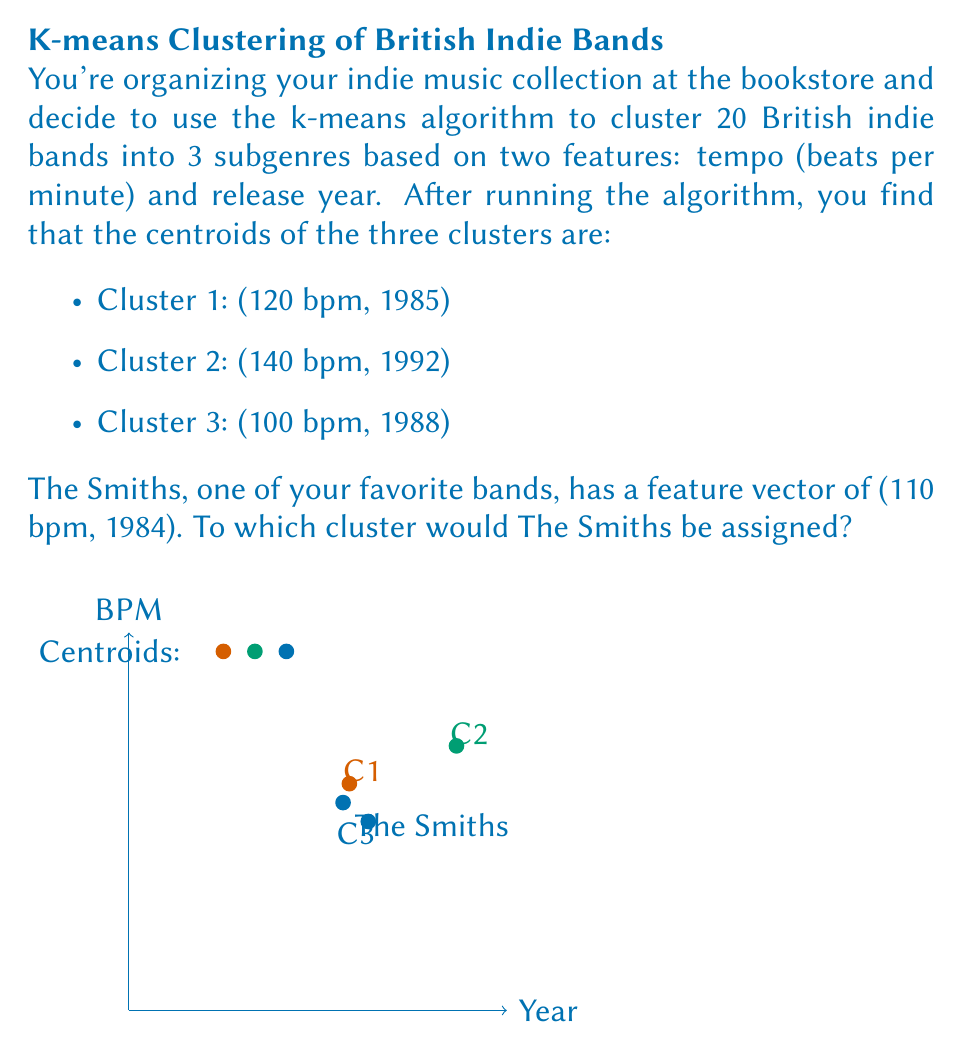Give your solution to this math problem. To determine which cluster The Smiths would be assigned to, we need to calculate the Euclidean distance between The Smiths' feature vector and each cluster centroid. The cluster with the shortest distance will be the one The Smiths is assigned to.

Let's calculate the distance to each centroid:

1. Normalize the features:
   - For tempo: divide by 100 (so 100 bpm becomes 1)
   - For year: subtract 1980 (so 1980 becomes 0)

2. The Smiths' normalized vector: (1.10, 4)

3. Normalized centroids:
   Cluster 1: (1.20, 5)
   Cluster 2: (1.40, 12)
   Cluster 3: (1.00, 8)

4. Calculate Euclidean distances:

   Distance to Cluster 1:
   $$d_1 = \sqrt{(1.10 - 1.20)^2 + (4 - 5)^2} = \sqrt{0.01 + 1} = \sqrt{1.01} \approx 1.005$$

   Distance to Cluster 2:
   $$d_2 = \sqrt{(1.10 - 1.40)^2 + (4 - 12)^2} = \sqrt{0.09 + 64} = \sqrt{64.09} \approx 8.006$$

   Distance to Cluster 3:
   $$d_3 = \sqrt{(1.10 - 1.00)^2 + (4 - 8)^2} = \sqrt{0.01 + 16} = \sqrt{16.01} \approx 4.001$$

5. The shortest distance is to Cluster 1 (1.005).

Therefore, The Smiths would be assigned to Cluster 1.
Answer: Cluster 1 